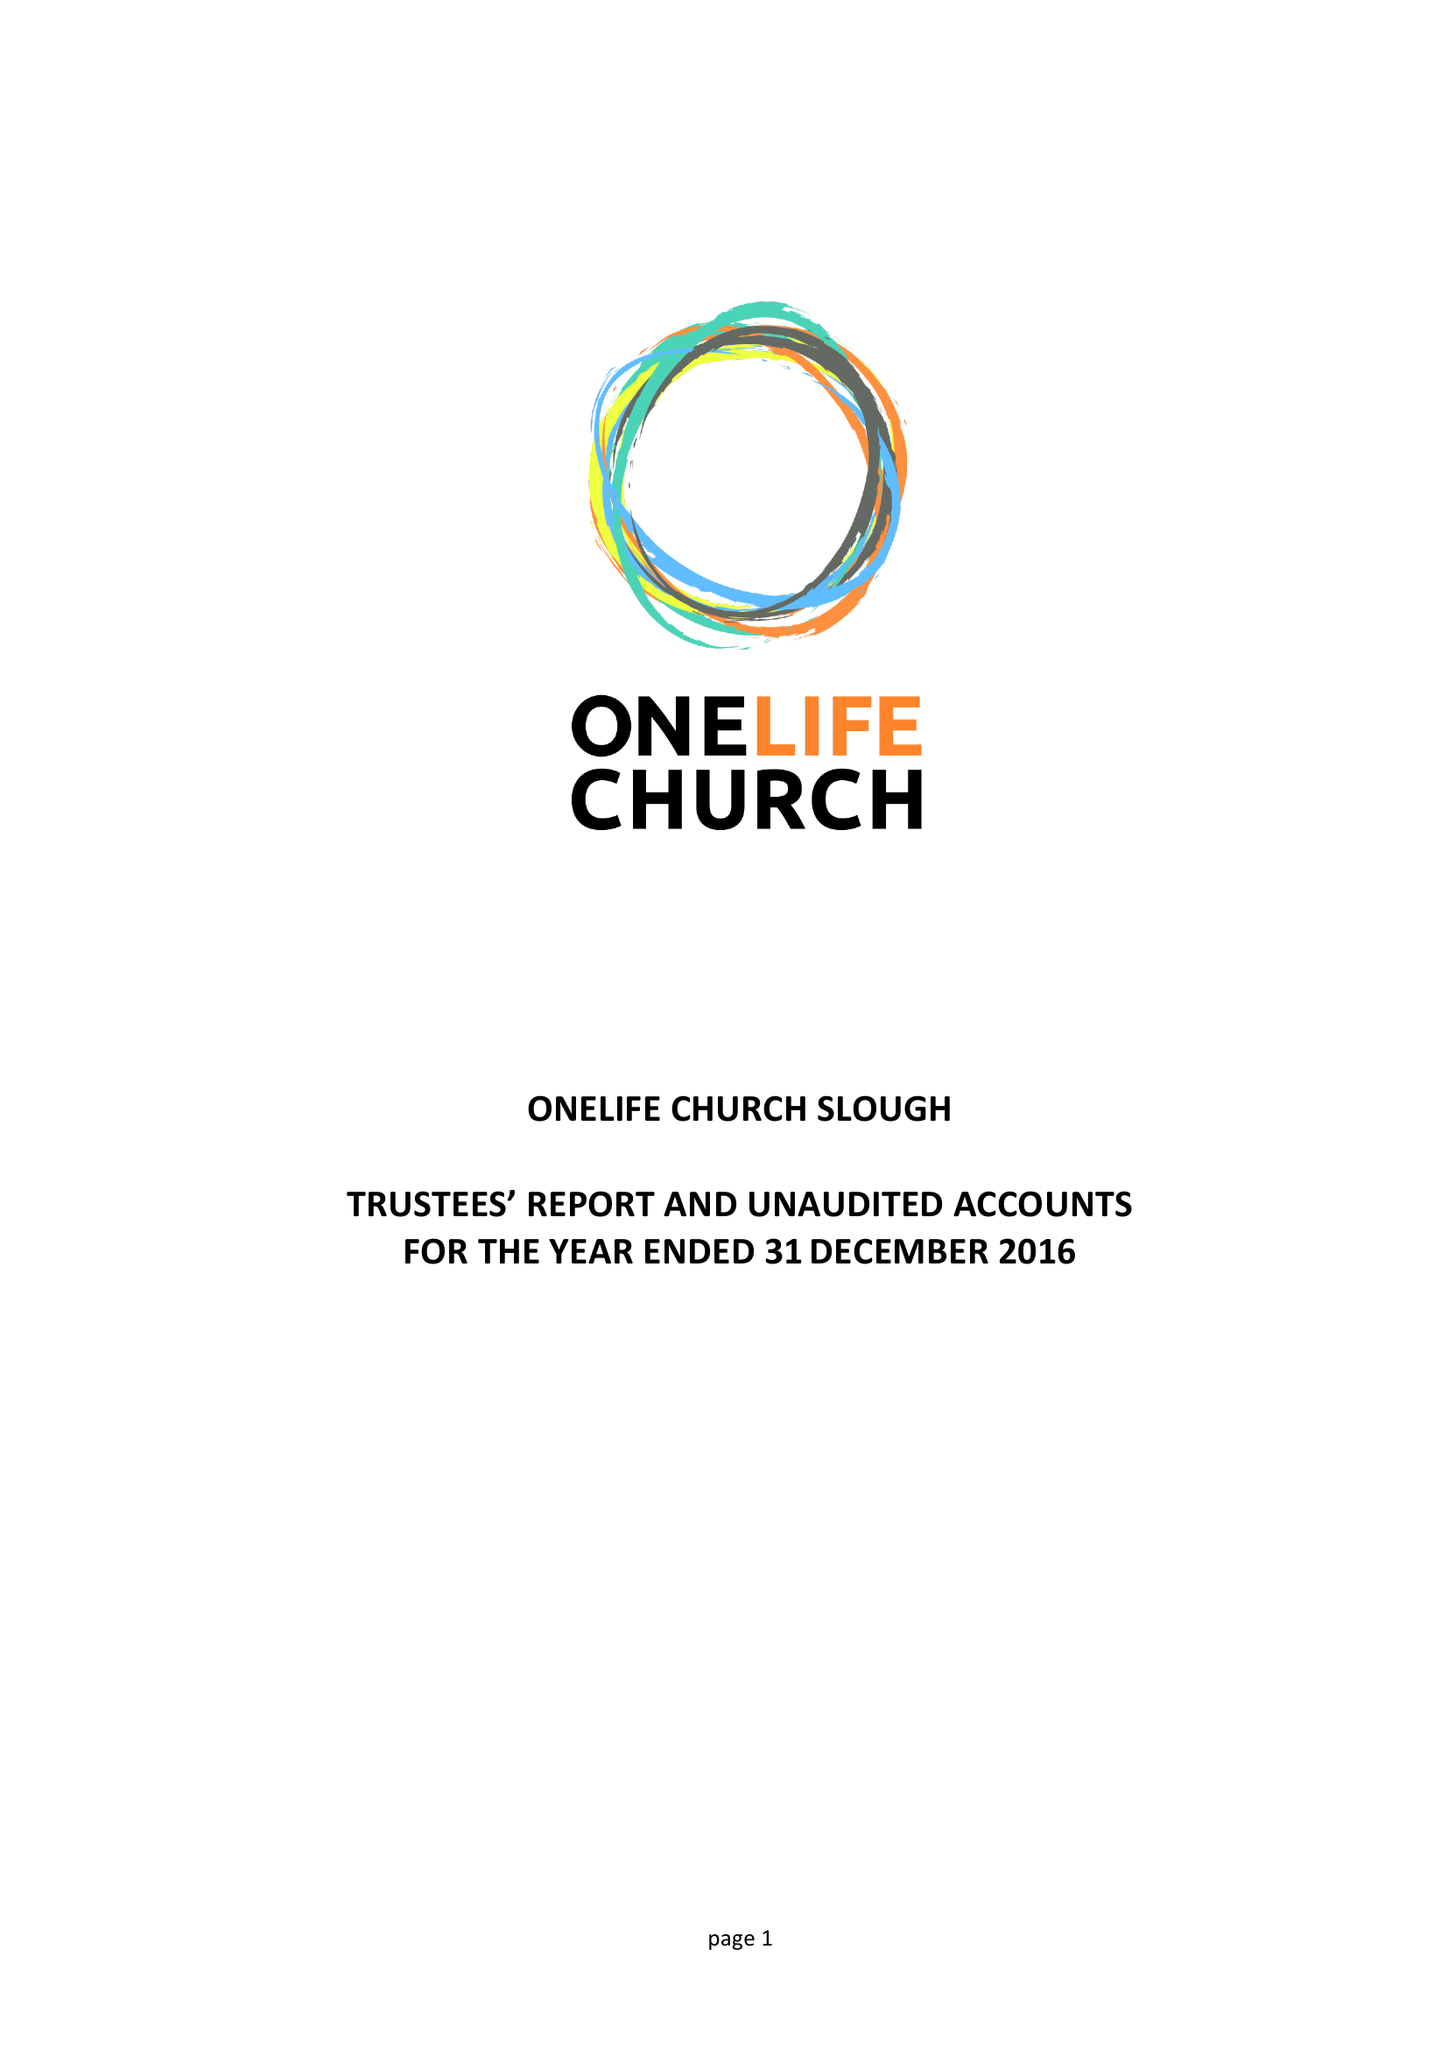What is the value for the report_date?
Answer the question using a single word or phrase. 2016-12-31 